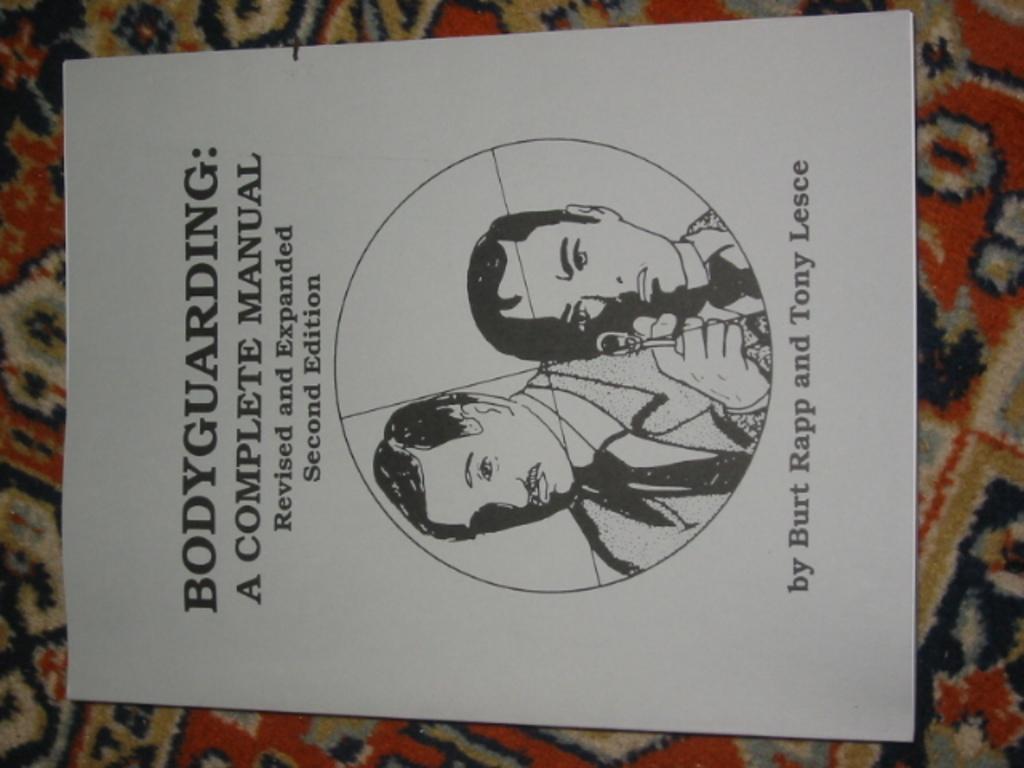What is this manual for?
Provide a succinct answer. Bodyguarding. Who is the manual authored by?
Your answer should be compact. Burt rapp and tony lesce. 